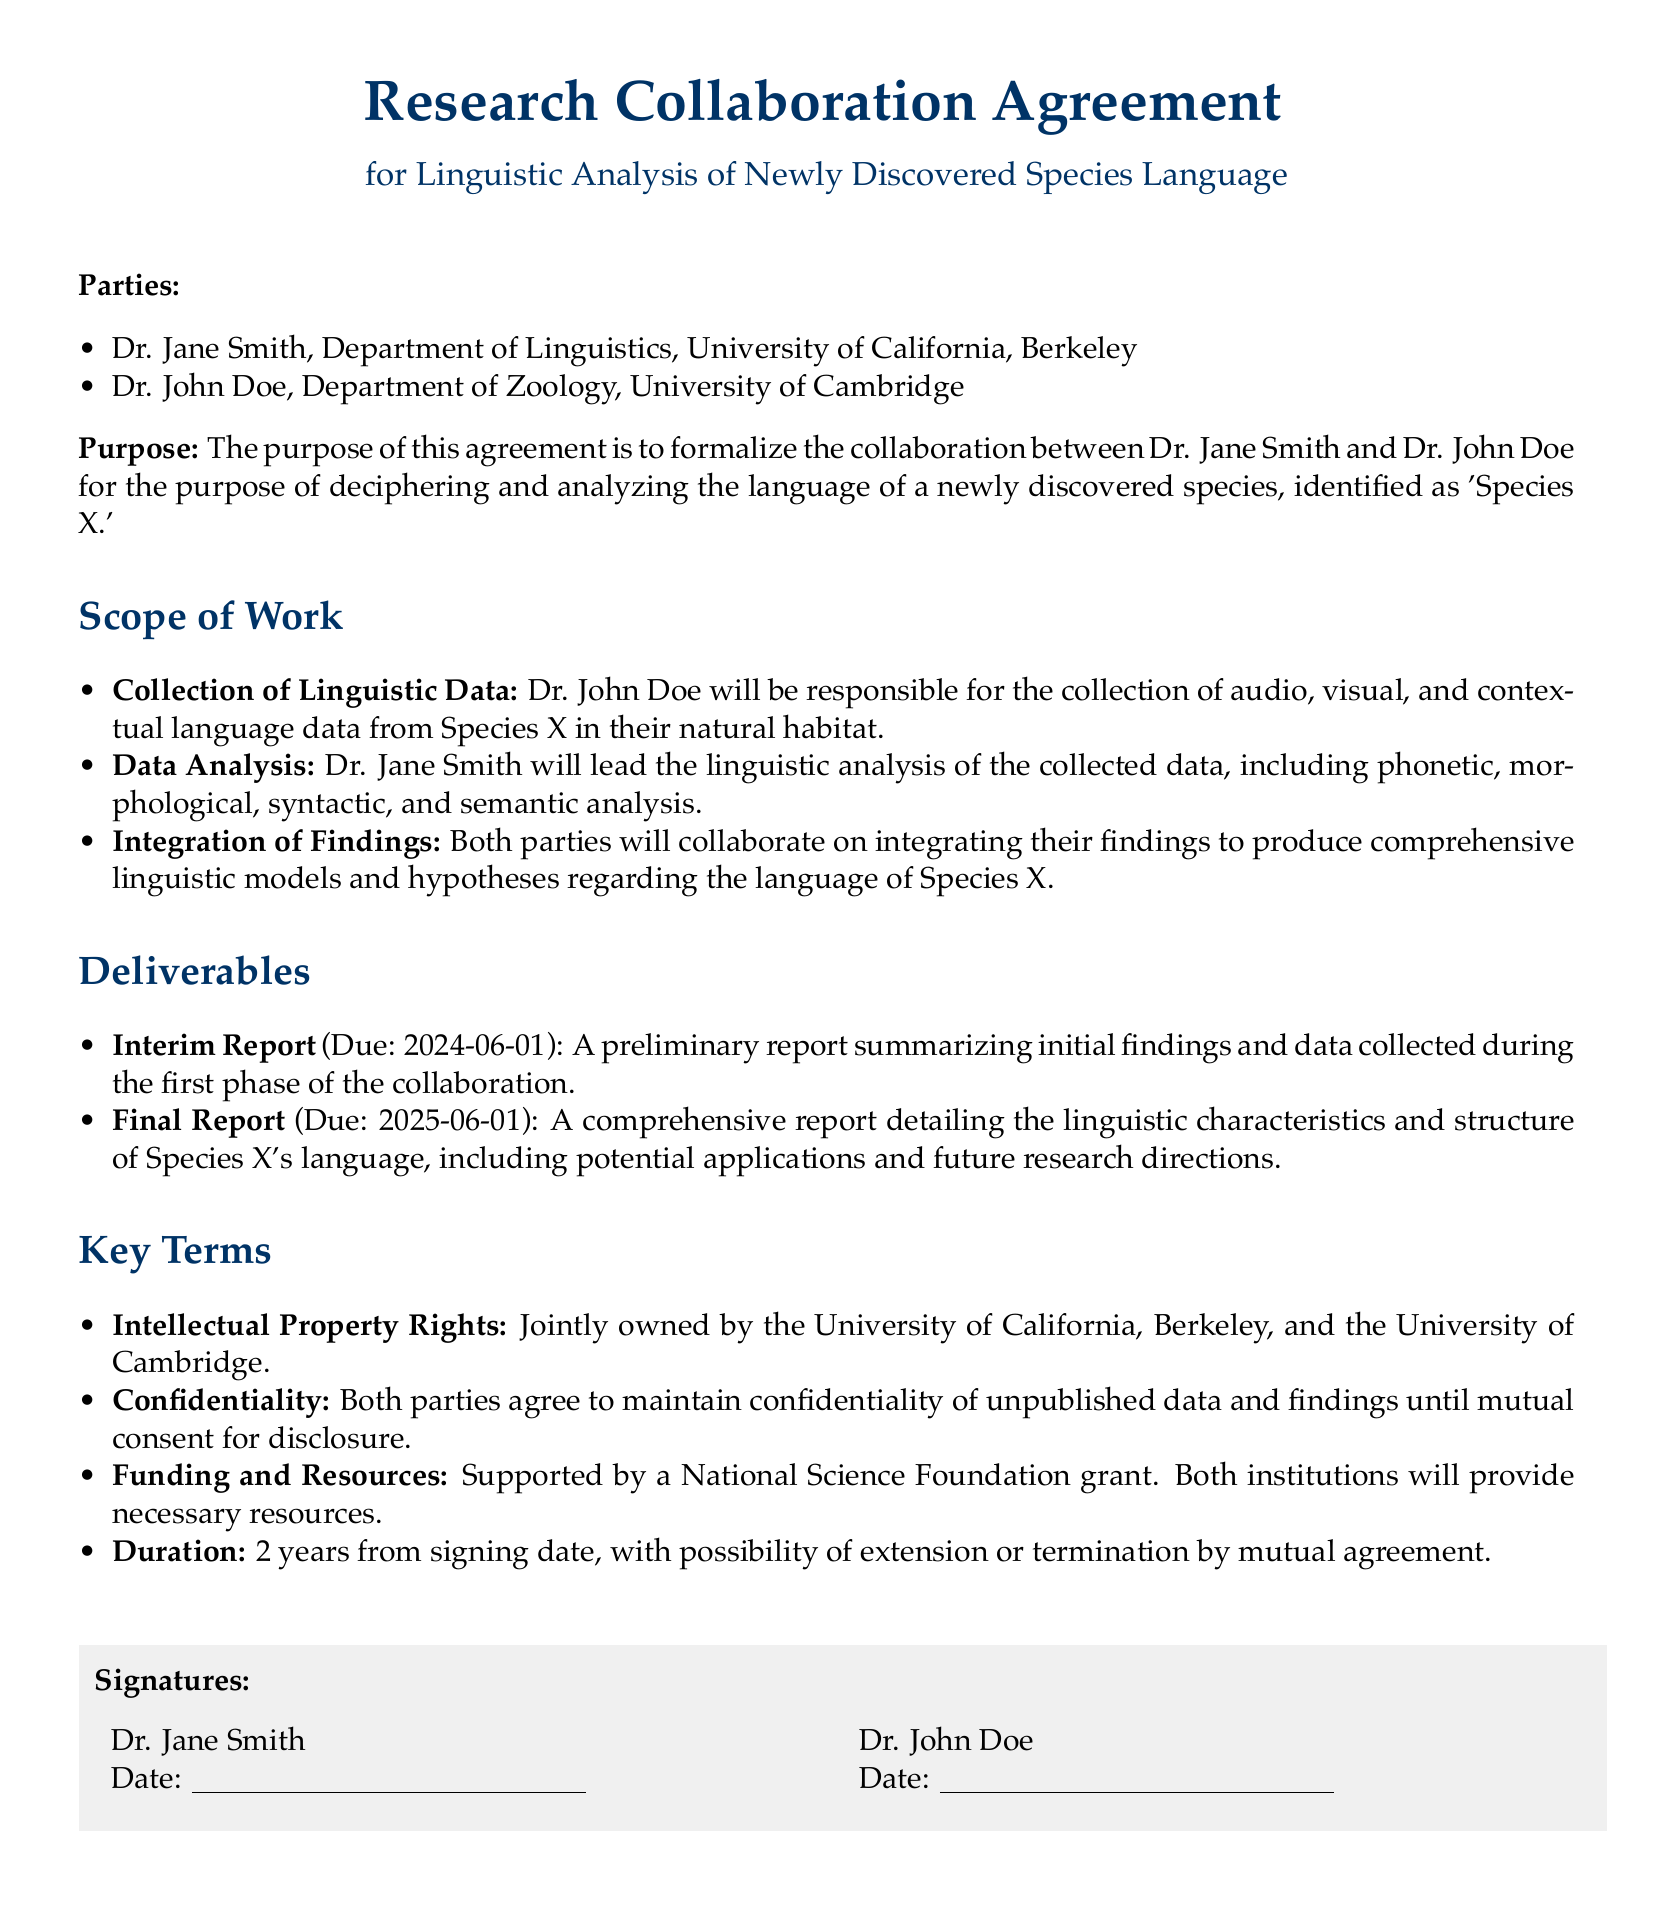What is the title of the document? The title of the document is specified in the introduction section, which states the formal title as "Research Collaboration Agreement for Linguistic Analysis of Newly Discovered Species Language."
Answer: Research Collaboration Agreement for Linguistic Analysis of Newly Discovered Species Language Who are the parties involved? The parties involved are listed in the document under the "Parties" section as Dr. Jane Smith and Dr. John Doe.
Answer: Dr. Jane Smith and Dr. John Doe What is the purpose of the agreement? The purpose is outlined in the document, describing the formal collaboration to decipher and analyze the language of 'Species X.'
Answer: Deciphering and analyzing the language of 'Species X.' What is the due date for the interim report? The due date for the interim report is specified under "Deliverables" as 2024-06-01.
Answer: 2024-06-01 How long is the duration of the agreement? The duration of the agreement is mentioned specifically in the "Key Terms" section, stating it to be 2 years.
Answer: 2 years Who will lead the linguistic analysis? The document clearly states that Dr. Jane Smith will lead the linguistic analysis of the data collected.
Answer: Dr. Jane Smith What grant supports this research? The supporting grant for this research is noted in the "Key Terms" section and identified as a National Science Foundation grant.
Answer: National Science Foundation What will Dr. John Doe be responsible for? The responsibilities of Dr. John Doe are detailed under "Scope of Work," emphasizing his role in the collection of linguistic data.
Answer: Collection of linguistic data When is the final report due? The final report's due date is clearly stated in the "Deliverables" section as 2025-06-01.
Answer: 2025-06-01 